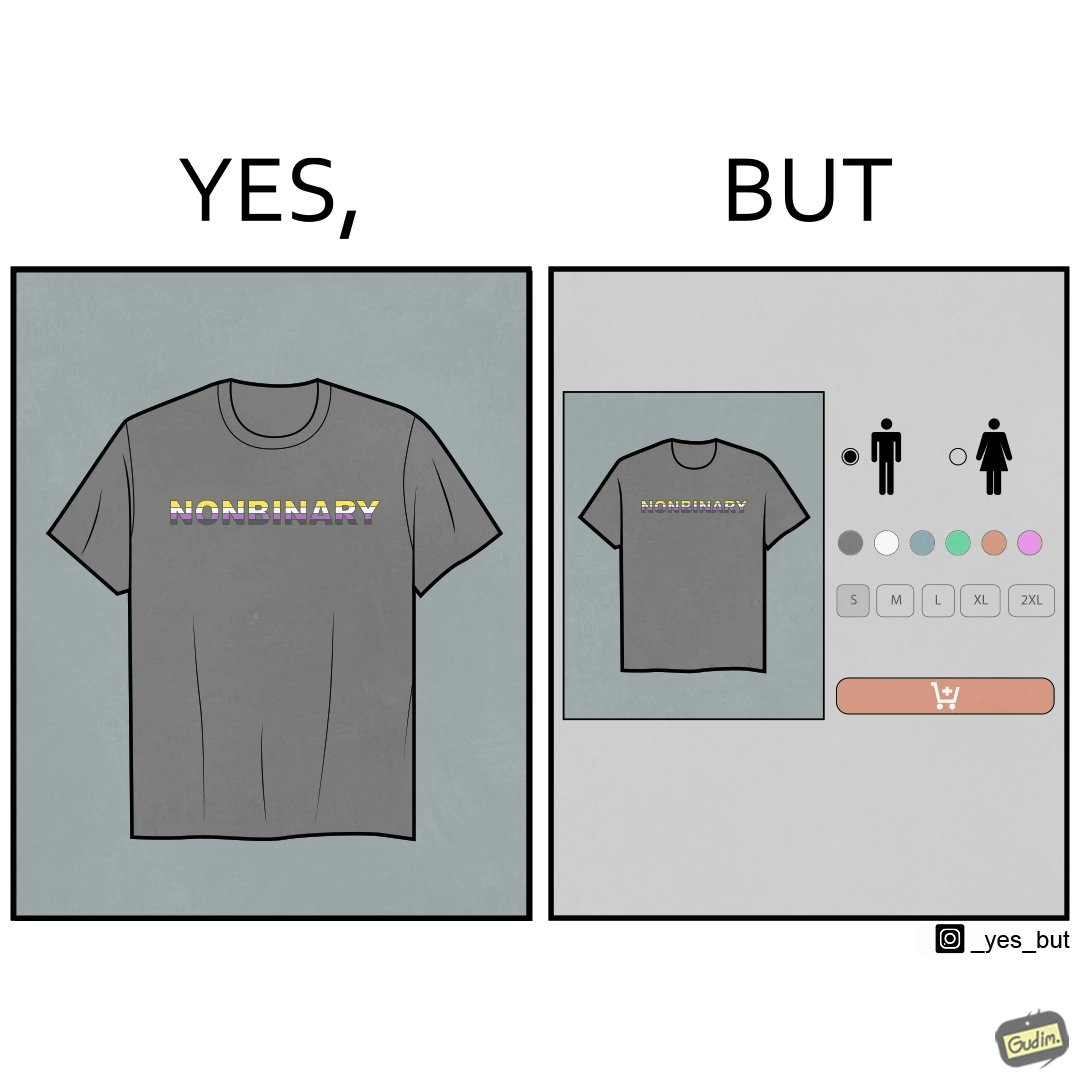Describe the content of this image. The image is ironic, as the t-shirt that says "NONBINARY" has only 2 options for gender on an online retail forum. 